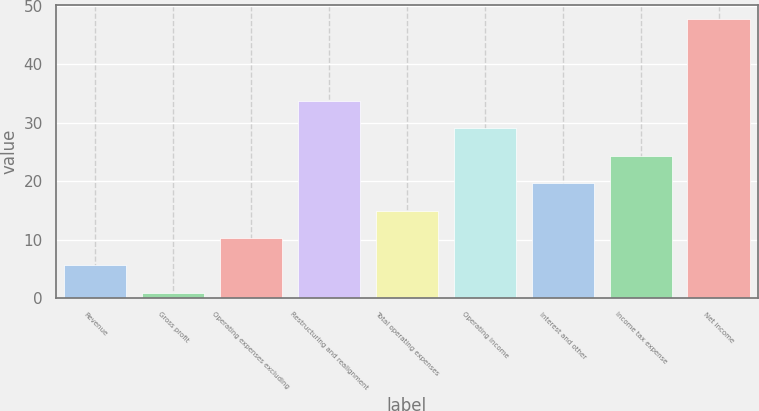<chart> <loc_0><loc_0><loc_500><loc_500><bar_chart><fcel>Revenue<fcel>Gross profit<fcel>Operating expenses excluding<fcel>Restructuring and realignment<fcel>Total operating expenses<fcel>Operating income<fcel>Interest and other<fcel>Income tax expense<fcel>Net income<nl><fcel>5.59<fcel>0.9<fcel>10.28<fcel>33.73<fcel>14.97<fcel>29.04<fcel>19.66<fcel>24.35<fcel>47.8<nl></chart> 